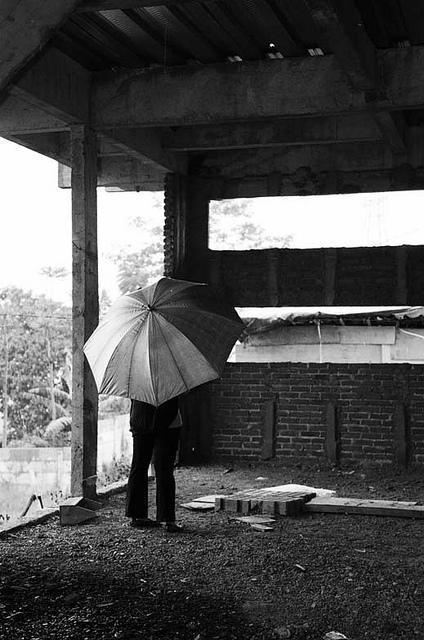How many buses are there?
Give a very brief answer. 0. 